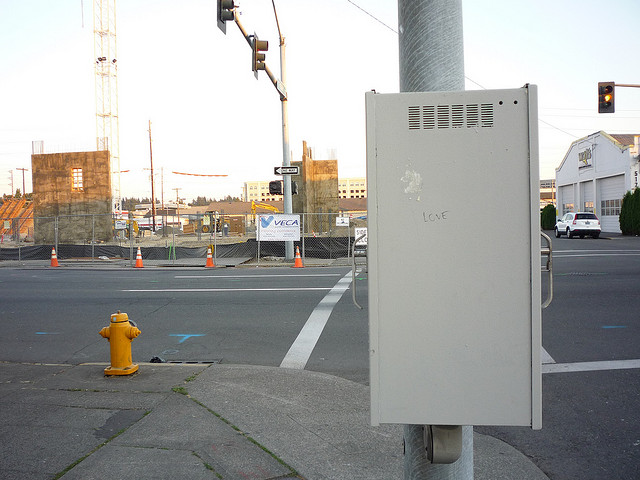Please transcribe the text in this image. Love VFCA T 